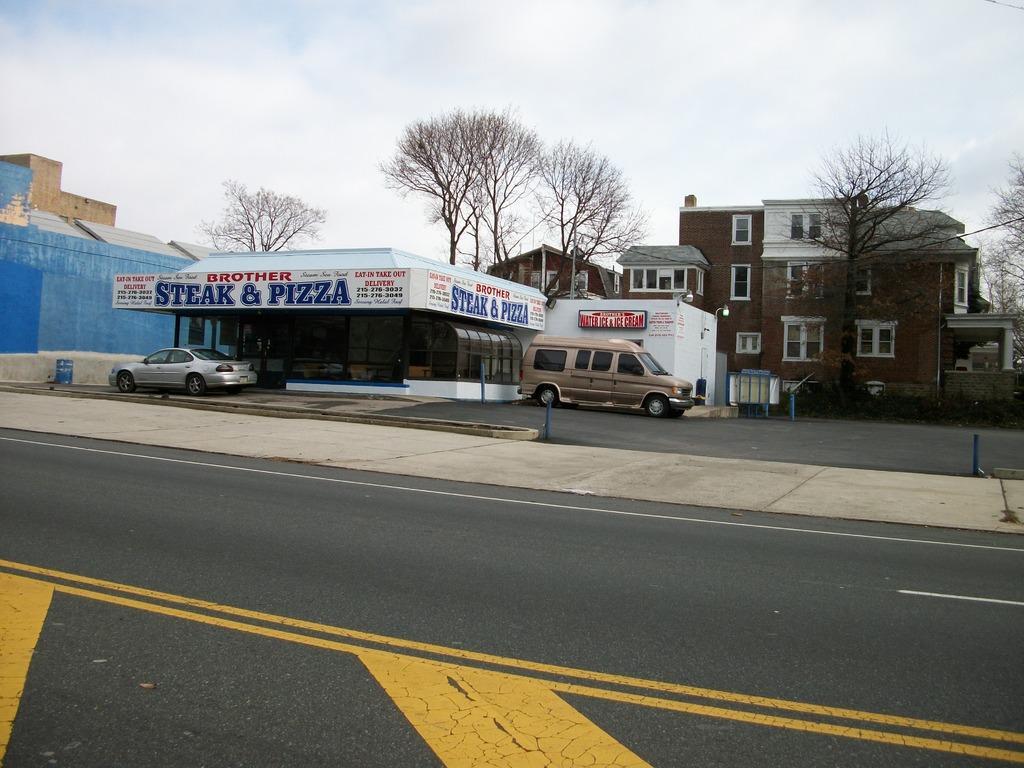How would you summarize this image in a sentence or two? In the picture we can see a road on it we can see a yellow color stripes and beside the road we can see a path with a shed and poles to it and near it we can see two vehicles and behind it we can see some dried trees and building with windows and glasses to it and in the background we can see a sky with clouds. 